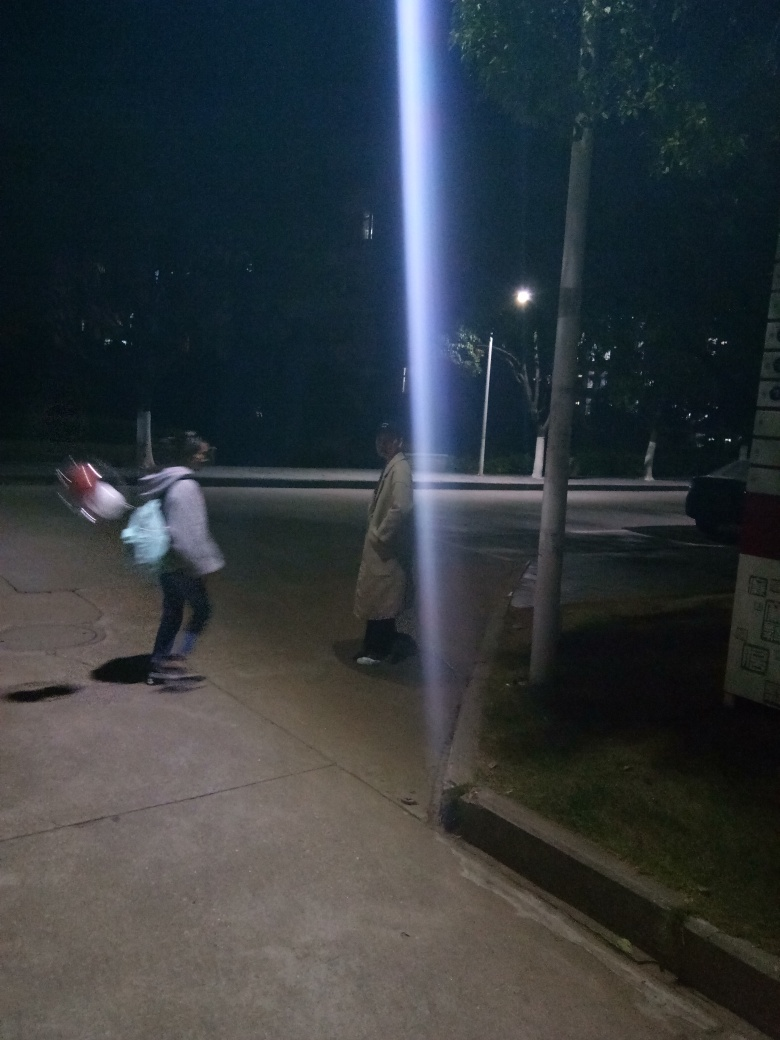What time of day does this image suggest, considering the lighting and environment? The image suggests it is nighttime, given the artificial lighting and darkness in the surroundings. The illumination from the lamppost and the overall darkness of the environment point to late evening hours after sunset. 